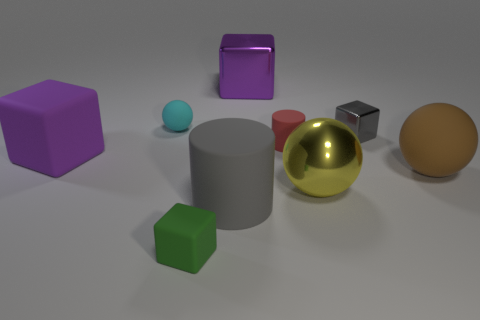Add 1 big blue matte spheres. How many objects exist? 10 Subtract all balls. How many objects are left? 6 Subtract all large cylinders. Subtract all gray cylinders. How many objects are left? 7 Add 6 large cylinders. How many large cylinders are left? 7 Add 8 green cylinders. How many green cylinders exist? 8 Subtract 0 yellow cylinders. How many objects are left? 9 